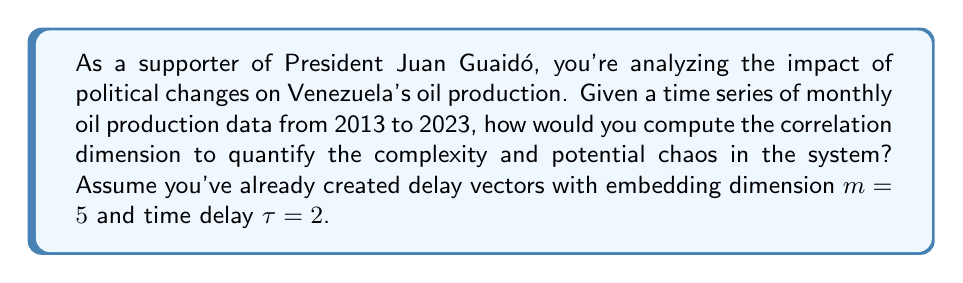Could you help me with this problem? To compute the correlation dimension for Venezuela's oil production time series:

1. Create delay vectors:
   Given $\{x_i\}_{i=1}^N$, form vectors $\vec{y}_i = (x_i, x_{i+\tau}, ..., x_{i+(m-1)\tau})$

2. Calculate pairwise distances:
   For each pair of vectors, compute Euclidean distance:
   $$d_{ij} = \|\vec{y}_i - \vec{y}_j\|$$

3. Compute correlation sum:
   For a range of $r$ values:
   $$C(r) = \frac{2}{N(N-1)} \sum_{i=1}^{N} \sum_{j=i+1}^{N} \Theta(r - d_{ij})$$
   where $\Theta$ is the Heaviside step function.

4. Plot $\log C(r)$ vs $\log r$:
   The slope of the linear region gives the correlation dimension.

5. Use least squares regression to find the slope:
   $$D_2 = \lim_{r \to 0} \frac{d \log C(r)}{d \log r}$$

6. Repeat for different embedding dimensions:
   If $D_2$ converges, it's the correlation dimension.

This analysis can reveal the complexity of Venezuela's oil production system, potentially showing how political changes under different leaderships affect the country's primary economic driver.
Answer: $D_2 = \lim_{r \to 0} \frac{d \log C(r)}{d \log r}$ 